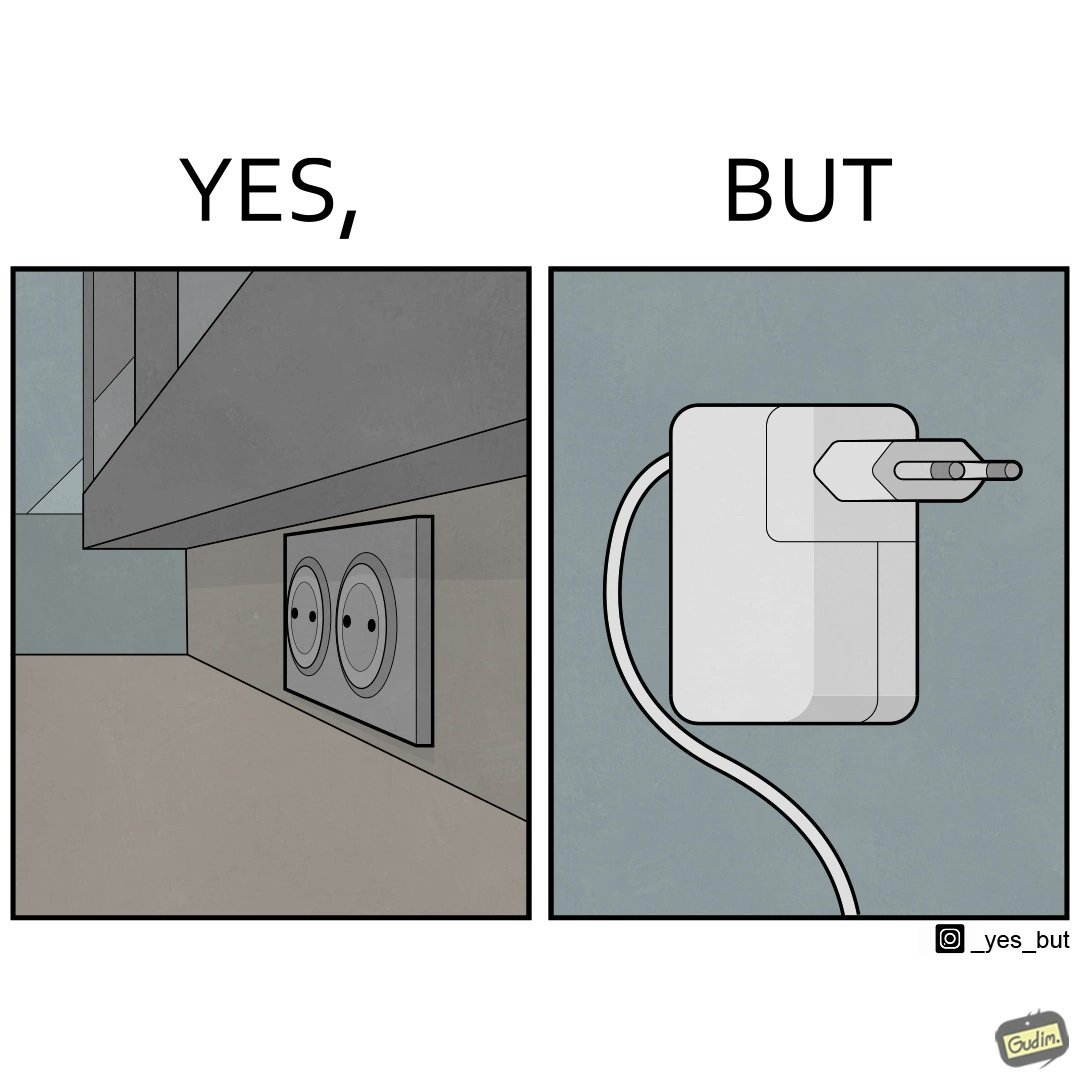What is shown in this image? The image is funny, as there are two electrical sockets side-by-side, but the adapter is shaped in such a way, that if two adapters are inserted into the two sockets, they will butt into each other, leading to inconvenience. 